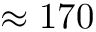Convert formula to latex. <formula><loc_0><loc_0><loc_500><loc_500>\approx 1 7 0</formula> 